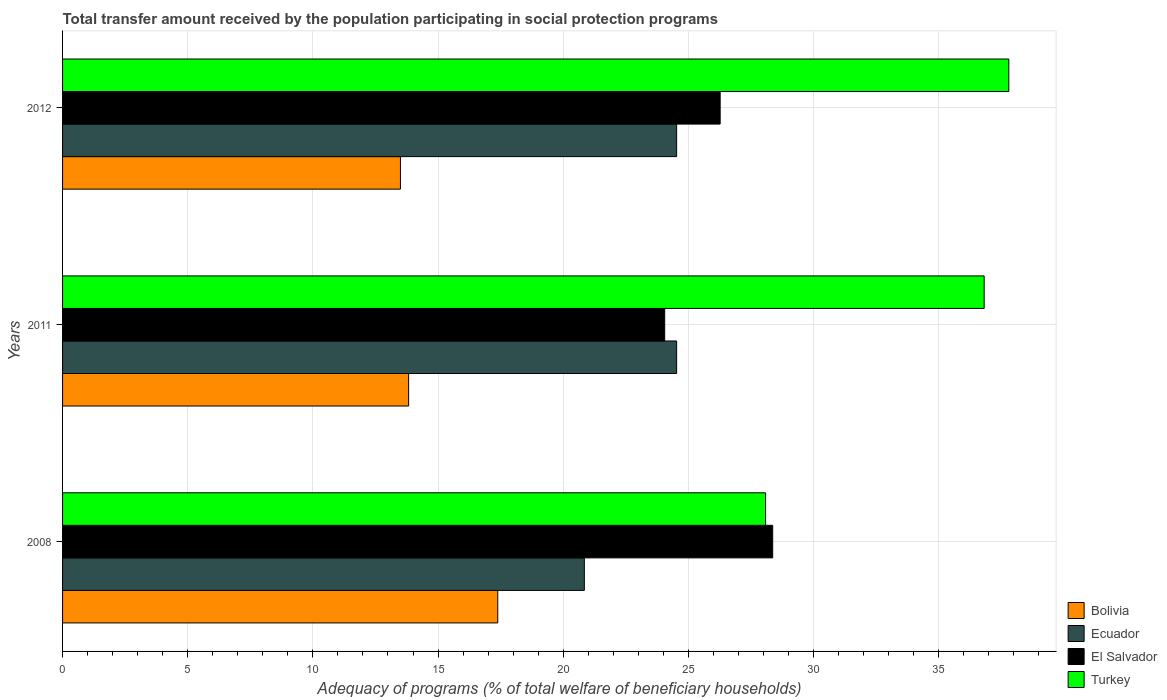Are the number of bars per tick equal to the number of legend labels?
Keep it short and to the point. Yes. How many bars are there on the 3rd tick from the top?
Offer a very short reply. 4. What is the label of the 1st group of bars from the top?
Provide a short and direct response. 2012. What is the total transfer amount received by the population in Bolivia in 2008?
Give a very brief answer. 17.39. Across all years, what is the maximum total transfer amount received by the population in Turkey?
Give a very brief answer. 37.8. Across all years, what is the minimum total transfer amount received by the population in Ecuador?
Give a very brief answer. 20.84. In which year was the total transfer amount received by the population in Bolivia maximum?
Make the answer very short. 2008. What is the total total transfer amount received by the population in Bolivia in the graph?
Offer a terse response. 44.71. What is the difference between the total transfer amount received by the population in Ecuador in 2008 and the total transfer amount received by the population in Turkey in 2012?
Your answer should be compact. -16.96. What is the average total transfer amount received by the population in Ecuador per year?
Give a very brief answer. 23.3. In the year 2008, what is the difference between the total transfer amount received by the population in Turkey and total transfer amount received by the population in Bolivia?
Make the answer very short. 10.7. What is the ratio of the total transfer amount received by the population in Turkey in 2008 to that in 2012?
Make the answer very short. 0.74. What is the difference between the highest and the second highest total transfer amount received by the population in El Salvador?
Ensure brevity in your answer.  2.1. What is the difference between the highest and the lowest total transfer amount received by the population in Turkey?
Give a very brief answer. 9.72. Is the sum of the total transfer amount received by the population in Bolivia in 2008 and 2012 greater than the maximum total transfer amount received by the population in Turkey across all years?
Offer a very short reply. No. Is it the case that in every year, the sum of the total transfer amount received by the population in Ecuador and total transfer amount received by the population in Bolivia is greater than the sum of total transfer amount received by the population in Turkey and total transfer amount received by the population in El Salvador?
Make the answer very short. Yes. What does the 2nd bar from the top in 2008 represents?
Your answer should be very brief. El Salvador. What does the 4th bar from the bottom in 2008 represents?
Give a very brief answer. Turkey. What is the difference between two consecutive major ticks on the X-axis?
Your answer should be compact. 5. Are the values on the major ticks of X-axis written in scientific E-notation?
Offer a very short reply. No. How many legend labels are there?
Provide a short and direct response. 4. How are the legend labels stacked?
Your answer should be compact. Vertical. What is the title of the graph?
Your answer should be compact. Total transfer amount received by the population participating in social protection programs. Does "South Africa" appear as one of the legend labels in the graph?
Keep it short and to the point. No. What is the label or title of the X-axis?
Offer a very short reply. Adequacy of programs (% of total welfare of beneficiary households). What is the Adequacy of programs (% of total welfare of beneficiary households) of Bolivia in 2008?
Offer a terse response. 17.39. What is the Adequacy of programs (% of total welfare of beneficiary households) in Ecuador in 2008?
Offer a very short reply. 20.84. What is the Adequacy of programs (% of total welfare of beneficiary households) of El Salvador in 2008?
Give a very brief answer. 28.37. What is the Adequacy of programs (% of total welfare of beneficiary households) of Turkey in 2008?
Offer a very short reply. 28.08. What is the Adequacy of programs (% of total welfare of beneficiary households) in Bolivia in 2011?
Give a very brief answer. 13.82. What is the Adequacy of programs (% of total welfare of beneficiary households) of Ecuador in 2011?
Provide a short and direct response. 24.53. What is the Adequacy of programs (% of total welfare of beneficiary households) in El Salvador in 2011?
Provide a succinct answer. 24.05. What is the Adequacy of programs (% of total welfare of beneficiary households) in Turkey in 2011?
Your answer should be compact. 36.82. What is the Adequacy of programs (% of total welfare of beneficiary households) in Bolivia in 2012?
Keep it short and to the point. 13.5. What is the Adequacy of programs (% of total welfare of beneficiary households) of Ecuador in 2012?
Keep it short and to the point. 24.53. What is the Adequacy of programs (% of total welfare of beneficiary households) in El Salvador in 2012?
Give a very brief answer. 26.27. What is the Adequacy of programs (% of total welfare of beneficiary households) in Turkey in 2012?
Give a very brief answer. 37.8. Across all years, what is the maximum Adequacy of programs (% of total welfare of beneficiary households) in Bolivia?
Ensure brevity in your answer.  17.39. Across all years, what is the maximum Adequacy of programs (% of total welfare of beneficiary households) in Ecuador?
Offer a terse response. 24.53. Across all years, what is the maximum Adequacy of programs (% of total welfare of beneficiary households) of El Salvador?
Provide a short and direct response. 28.37. Across all years, what is the maximum Adequacy of programs (% of total welfare of beneficiary households) of Turkey?
Provide a short and direct response. 37.8. Across all years, what is the minimum Adequacy of programs (% of total welfare of beneficiary households) of Bolivia?
Give a very brief answer. 13.5. Across all years, what is the minimum Adequacy of programs (% of total welfare of beneficiary households) of Ecuador?
Provide a short and direct response. 20.84. Across all years, what is the minimum Adequacy of programs (% of total welfare of beneficiary households) of El Salvador?
Give a very brief answer. 24.05. Across all years, what is the minimum Adequacy of programs (% of total welfare of beneficiary households) in Turkey?
Your response must be concise. 28.08. What is the total Adequacy of programs (% of total welfare of beneficiary households) in Bolivia in the graph?
Make the answer very short. 44.71. What is the total Adequacy of programs (% of total welfare of beneficiary households) in Ecuador in the graph?
Give a very brief answer. 69.9. What is the total Adequacy of programs (% of total welfare of beneficiary households) of El Salvador in the graph?
Your answer should be compact. 78.69. What is the total Adequacy of programs (% of total welfare of beneficiary households) in Turkey in the graph?
Offer a terse response. 102.7. What is the difference between the Adequacy of programs (% of total welfare of beneficiary households) of Bolivia in 2008 and that in 2011?
Your answer should be compact. 3.56. What is the difference between the Adequacy of programs (% of total welfare of beneficiary households) of Ecuador in 2008 and that in 2011?
Keep it short and to the point. -3.69. What is the difference between the Adequacy of programs (% of total welfare of beneficiary households) of El Salvador in 2008 and that in 2011?
Make the answer very short. 4.31. What is the difference between the Adequacy of programs (% of total welfare of beneficiary households) of Turkey in 2008 and that in 2011?
Offer a very short reply. -8.73. What is the difference between the Adequacy of programs (% of total welfare of beneficiary households) of Bolivia in 2008 and that in 2012?
Offer a very short reply. 3.89. What is the difference between the Adequacy of programs (% of total welfare of beneficiary households) of Ecuador in 2008 and that in 2012?
Make the answer very short. -3.69. What is the difference between the Adequacy of programs (% of total welfare of beneficiary households) of El Salvador in 2008 and that in 2012?
Your response must be concise. 2.1. What is the difference between the Adequacy of programs (% of total welfare of beneficiary households) in Turkey in 2008 and that in 2012?
Ensure brevity in your answer.  -9.72. What is the difference between the Adequacy of programs (% of total welfare of beneficiary households) of Bolivia in 2011 and that in 2012?
Offer a terse response. 0.33. What is the difference between the Adequacy of programs (% of total welfare of beneficiary households) in El Salvador in 2011 and that in 2012?
Offer a terse response. -2.22. What is the difference between the Adequacy of programs (% of total welfare of beneficiary households) of Turkey in 2011 and that in 2012?
Make the answer very short. -0.98. What is the difference between the Adequacy of programs (% of total welfare of beneficiary households) in Bolivia in 2008 and the Adequacy of programs (% of total welfare of beneficiary households) in Ecuador in 2011?
Make the answer very short. -7.14. What is the difference between the Adequacy of programs (% of total welfare of beneficiary households) of Bolivia in 2008 and the Adequacy of programs (% of total welfare of beneficiary households) of El Salvador in 2011?
Your answer should be compact. -6.67. What is the difference between the Adequacy of programs (% of total welfare of beneficiary households) of Bolivia in 2008 and the Adequacy of programs (% of total welfare of beneficiary households) of Turkey in 2011?
Give a very brief answer. -19.43. What is the difference between the Adequacy of programs (% of total welfare of beneficiary households) in Ecuador in 2008 and the Adequacy of programs (% of total welfare of beneficiary households) in El Salvador in 2011?
Ensure brevity in your answer.  -3.21. What is the difference between the Adequacy of programs (% of total welfare of beneficiary households) in Ecuador in 2008 and the Adequacy of programs (% of total welfare of beneficiary households) in Turkey in 2011?
Keep it short and to the point. -15.97. What is the difference between the Adequacy of programs (% of total welfare of beneficiary households) in El Salvador in 2008 and the Adequacy of programs (% of total welfare of beneficiary households) in Turkey in 2011?
Make the answer very short. -8.45. What is the difference between the Adequacy of programs (% of total welfare of beneficiary households) of Bolivia in 2008 and the Adequacy of programs (% of total welfare of beneficiary households) of Ecuador in 2012?
Your answer should be very brief. -7.14. What is the difference between the Adequacy of programs (% of total welfare of beneficiary households) in Bolivia in 2008 and the Adequacy of programs (% of total welfare of beneficiary households) in El Salvador in 2012?
Make the answer very short. -8.88. What is the difference between the Adequacy of programs (% of total welfare of beneficiary households) in Bolivia in 2008 and the Adequacy of programs (% of total welfare of beneficiary households) in Turkey in 2012?
Make the answer very short. -20.41. What is the difference between the Adequacy of programs (% of total welfare of beneficiary households) of Ecuador in 2008 and the Adequacy of programs (% of total welfare of beneficiary households) of El Salvador in 2012?
Your answer should be compact. -5.43. What is the difference between the Adequacy of programs (% of total welfare of beneficiary households) of Ecuador in 2008 and the Adequacy of programs (% of total welfare of beneficiary households) of Turkey in 2012?
Ensure brevity in your answer.  -16.96. What is the difference between the Adequacy of programs (% of total welfare of beneficiary households) in El Salvador in 2008 and the Adequacy of programs (% of total welfare of beneficiary households) in Turkey in 2012?
Provide a short and direct response. -9.43. What is the difference between the Adequacy of programs (% of total welfare of beneficiary households) of Bolivia in 2011 and the Adequacy of programs (% of total welfare of beneficiary households) of Ecuador in 2012?
Ensure brevity in your answer.  -10.71. What is the difference between the Adequacy of programs (% of total welfare of beneficiary households) in Bolivia in 2011 and the Adequacy of programs (% of total welfare of beneficiary households) in El Salvador in 2012?
Ensure brevity in your answer.  -12.45. What is the difference between the Adequacy of programs (% of total welfare of beneficiary households) of Bolivia in 2011 and the Adequacy of programs (% of total welfare of beneficiary households) of Turkey in 2012?
Offer a very short reply. -23.98. What is the difference between the Adequacy of programs (% of total welfare of beneficiary households) of Ecuador in 2011 and the Adequacy of programs (% of total welfare of beneficiary households) of El Salvador in 2012?
Provide a short and direct response. -1.74. What is the difference between the Adequacy of programs (% of total welfare of beneficiary households) in Ecuador in 2011 and the Adequacy of programs (% of total welfare of beneficiary households) in Turkey in 2012?
Offer a very short reply. -13.27. What is the difference between the Adequacy of programs (% of total welfare of beneficiary households) of El Salvador in 2011 and the Adequacy of programs (% of total welfare of beneficiary households) of Turkey in 2012?
Offer a terse response. -13.75. What is the average Adequacy of programs (% of total welfare of beneficiary households) of Bolivia per year?
Keep it short and to the point. 14.9. What is the average Adequacy of programs (% of total welfare of beneficiary households) of Ecuador per year?
Your response must be concise. 23.3. What is the average Adequacy of programs (% of total welfare of beneficiary households) of El Salvador per year?
Provide a short and direct response. 26.23. What is the average Adequacy of programs (% of total welfare of beneficiary households) in Turkey per year?
Keep it short and to the point. 34.23. In the year 2008, what is the difference between the Adequacy of programs (% of total welfare of beneficiary households) in Bolivia and Adequacy of programs (% of total welfare of beneficiary households) in Ecuador?
Make the answer very short. -3.46. In the year 2008, what is the difference between the Adequacy of programs (% of total welfare of beneficiary households) of Bolivia and Adequacy of programs (% of total welfare of beneficiary households) of El Salvador?
Provide a short and direct response. -10.98. In the year 2008, what is the difference between the Adequacy of programs (% of total welfare of beneficiary households) of Bolivia and Adequacy of programs (% of total welfare of beneficiary households) of Turkey?
Your response must be concise. -10.7. In the year 2008, what is the difference between the Adequacy of programs (% of total welfare of beneficiary households) in Ecuador and Adequacy of programs (% of total welfare of beneficiary households) in El Salvador?
Your answer should be very brief. -7.52. In the year 2008, what is the difference between the Adequacy of programs (% of total welfare of beneficiary households) in Ecuador and Adequacy of programs (% of total welfare of beneficiary households) in Turkey?
Keep it short and to the point. -7.24. In the year 2008, what is the difference between the Adequacy of programs (% of total welfare of beneficiary households) in El Salvador and Adequacy of programs (% of total welfare of beneficiary households) in Turkey?
Give a very brief answer. 0.28. In the year 2011, what is the difference between the Adequacy of programs (% of total welfare of beneficiary households) of Bolivia and Adequacy of programs (% of total welfare of beneficiary households) of Ecuador?
Offer a very short reply. -10.71. In the year 2011, what is the difference between the Adequacy of programs (% of total welfare of beneficiary households) in Bolivia and Adequacy of programs (% of total welfare of beneficiary households) in El Salvador?
Ensure brevity in your answer.  -10.23. In the year 2011, what is the difference between the Adequacy of programs (% of total welfare of beneficiary households) of Bolivia and Adequacy of programs (% of total welfare of beneficiary households) of Turkey?
Give a very brief answer. -22.99. In the year 2011, what is the difference between the Adequacy of programs (% of total welfare of beneficiary households) of Ecuador and Adequacy of programs (% of total welfare of beneficiary households) of El Salvador?
Offer a terse response. 0.48. In the year 2011, what is the difference between the Adequacy of programs (% of total welfare of beneficiary households) in Ecuador and Adequacy of programs (% of total welfare of beneficiary households) in Turkey?
Provide a succinct answer. -12.29. In the year 2011, what is the difference between the Adequacy of programs (% of total welfare of beneficiary households) of El Salvador and Adequacy of programs (% of total welfare of beneficiary households) of Turkey?
Your answer should be very brief. -12.76. In the year 2012, what is the difference between the Adequacy of programs (% of total welfare of beneficiary households) in Bolivia and Adequacy of programs (% of total welfare of beneficiary households) in Ecuador?
Offer a very short reply. -11.03. In the year 2012, what is the difference between the Adequacy of programs (% of total welfare of beneficiary households) in Bolivia and Adequacy of programs (% of total welfare of beneficiary households) in El Salvador?
Give a very brief answer. -12.77. In the year 2012, what is the difference between the Adequacy of programs (% of total welfare of beneficiary households) of Bolivia and Adequacy of programs (% of total welfare of beneficiary households) of Turkey?
Your answer should be compact. -24.3. In the year 2012, what is the difference between the Adequacy of programs (% of total welfare of beneficiary households) of Ecuador and Adequacy of programs (% of total welfare of beneficiary households) of El Salvador?
Give a very brief answer. -1.74. In the year 2012, what is the difference between the Adequacy of programs (% of total welfare of beneficiary households) in Ecuador and Adequacy of programs (% of total welfare of beneficiary households) in Turkey?
Give a very brief answer. -13.27. In the year 2012, what is the difference between the Adequacy of programs (% of total welfare of beneficiary households) in El Salvador and Adequacy of programs (% of total welfare of beneficiary households) in Turkey?
Your response must be concise. -11.53. What is the ratio of the Adequacy of programs (% of total welfare of beneficiary households) in Bolivia in 2008 to that in 2011?
Offer a very short reply. 1.26. What is the ratio of the Adequacy of programs (% of total welfare of beneficiary households) in Ecuador in 2008 to that in 2011?
Provide a short and direct response. 0.85. What is the ratio of the Adequacy of programs (% of total welfare of beneficiary households) in El Salvador in 2008 to that in 2011?
Provide a short and direct response. 1.18. What is the ratio of the Adequacy of programs (% of total welfare of beneficiary households) in Turkey in 2008 to that in 2011?
Ensure brevity in your answer.  0.76. What is the ratio of the Adequacy of programs (% of total welfare of beneficiary households) in Bolivia in 2008 to that in 2012?
Ensure brevity in your answer.  1.29. What is the ratio of the Adequacy of programs (% of total welfare of beneficiary households) in Ecuador in 2008 to that in 2012?
Your response must be concise. 0.85. What is the ratio of the Adequacy of programs (% of total welfare of beneficiary households) in El Salvador in 2008 to that in 2012?
Ensure brevity in your answer.  1.08. What is the ratio of the Adequacy of programs (% of total welfare of beneficiary households) of Turkey in 2008 to that in 2012?
Your answer should be very brief. 0.74. What is the ratio of the Adequacy of programs (% of total welfare of beneficiary households) in Bolivia in 2011 to that in 2012?
Make the answer very short. 1.02. What is the ratio of the Adequacy of programs (% of total welfare of beneficiary households) of Ecuador in 2011 to that in 2012?
Make the answer very short. 1. What is the ratio of the Adequacy of programs (% of total welfare of beneficiary households) in El Salvador in 2011 to that in 2012?
Provide a short and direct response. 0.92. What is the ratio of the Adequacy of programs (% of total welfare of beneficiary households) in Turkey in 2011 to that in 2012?
Give a very brief answer. 0.97. What is the difference between the highest and the second highest Adequacy of programs (% of total welfare of beneficiary households) in Bolivia?
Make the answer very short. 3.56. What is the difference between the highest and the second highest Adequacy of programs (% of total welfare of beneficiary households) in El Salvador?
Ensure brevity in your answer.  2.1. What is the difference between the highest and the second highest Adequacy of programs (% of total welfare of beneficiary households) of Turkey?
Offer a terse response. 0.98. What is the difference between the highest and the lowest Adequacy of programs (% of total welfare of beneficiary households) in Bolivia?
Make the answer very short. 3.89. What is the difference between the highest and the lowest Adequacy of programs (% of total welfare of beneficiary households) in Ecuador?
Your response must be concise. 3.69. What is the difference between the highest and the lowest Adequacy of programs (% of total welfare of beneficiary households) in El Salvador?
Your answer should be compact. 4.31. What is the difference between the highest and the lowest Adequacy of programs (% of total welfare of beneficiary households) in Turkey?
Offer a very short reply. 9.72. 